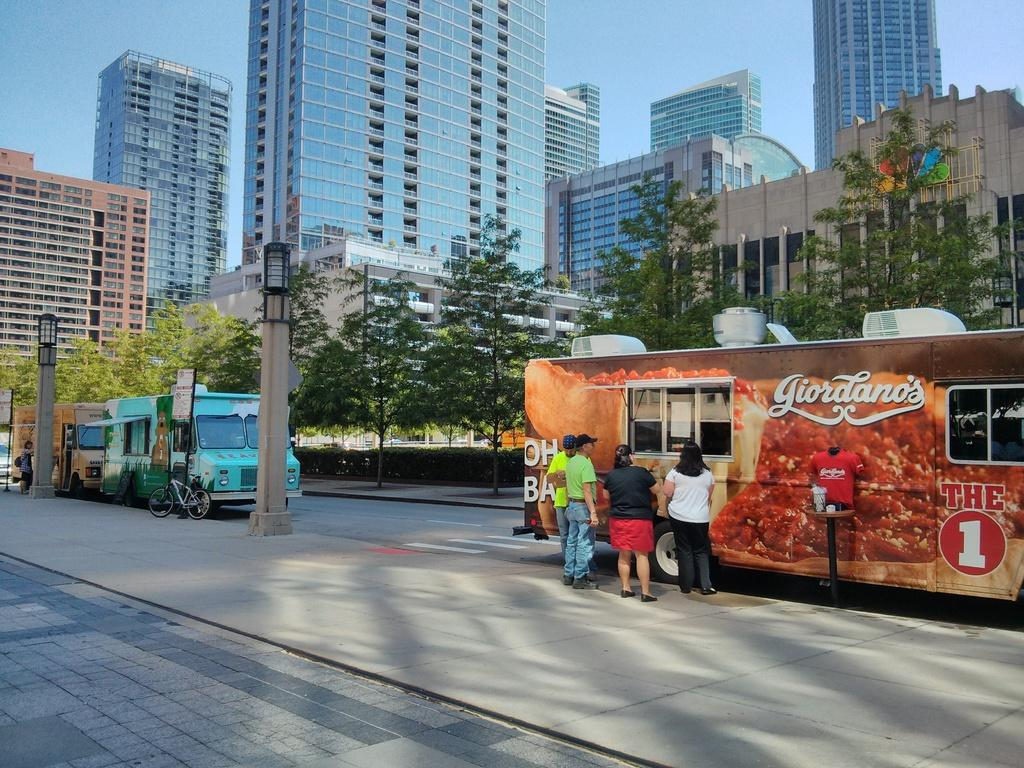What is happening on the road in the image? There are vehicles on the road in the image. Are there any people present near the road? Yes, there are people standing near the road in the image. What can be seen in the background of the image? There are buildings visible in the image. What type of natural elements are present in the image? There are trees in the image. What type of chair is being used to support the beam in the image? There is no chair or beam present in the image. What is the need for the people standing near the road in the image? The image does not provide information about the reason or need for the people standing near the road. 